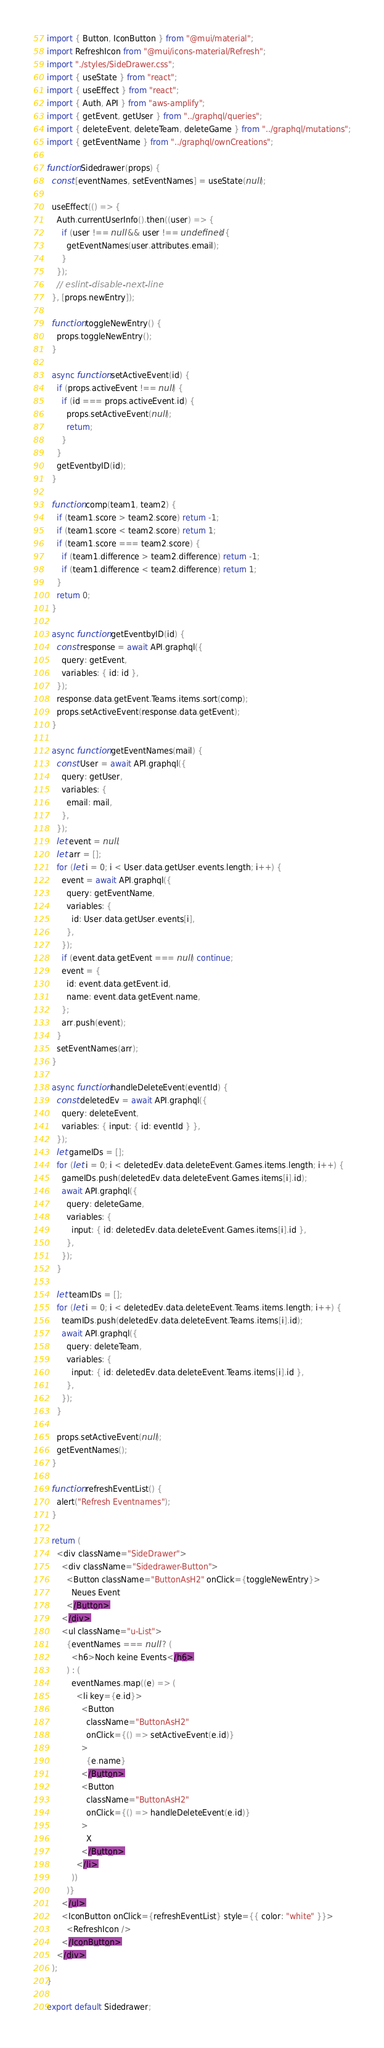Convert code to text. <code><loc_0><loc_0><loc_500><loc_500><_JavaScript_>import { Button, IconButton } from "@mui/material";
import RefreshIcon from "@mui/icons-material/Refresh";
import "./styles/SideDrawer.css";
import { useState } from "react";
import { useEffect } from "react";
import { Auth, API } from "aws-amplify";
import { getEvent, getUser } from "../graphql/queries";
import { deleteEvent, deleteTeam, deleteGame } from "../graphql/mutations";
import { getEventName } from "../graphql/ownCreations";

function Sidedrawer(props) {
  const [eventNames, setEventNames] = useState(null);

  useEffect(() => {
    Auth.currentUserInfo().then((user) => {
      if (user !== null && user !== undefined) {
        getEventNames(user.attributes.email);
      }
    });
    // eslint-disable-next-line
  }, [props.newEntry]);

  function toggleNewEntry() {
    props.toggleNewEntry();
  }

  async function setActiveEvent(id) {
    if (props.activeEvent !== null) {
      if (id === props.activeEvent.id) {
        props.setActiveEvent(null);
        return;
      }
    }
    getEventbyID(id);
  }

  function comp(team1, team2) {
    if (team1.score > team2.score) return -1;
    if (team1.score < team2.score) return 1;
    if (team1.score === team2.score) {
      if (team1.difference > team2.difference) return -1;
      if (team1.difference < team2.difference) return 1;
    }
    return 0;
  }

  async function getEventbyID(id) {
    const response = await API.graphql({
      query: getEvent,
      variables: { id: id },
    });
    response.data.getEvent.Teams.items.sort(comp);
    props.setActiveEvent(response.data.getEvent);
  }

  async function getEventNames(mail) {
    const User = await API.graphql({
      query: getUser,
      variables: {
        email: mail,
      },
    });
    let event = null;
    let arr = [];
    for (let i = 0; i < User.data.getUser.events.length; i++) {
      event = await API.graphql({
        query: getEventName,
        variables: {
          id: User.data.getUser.events[i],
        },
      });
      if (event.data.getEvent === null) continue;
      event = {
        id: event.data.getEvent.id,
        name: event.data.getEvent.name,
      };
      arr.push(event);
    }
    setEventNames(arr);
  }

  async function handleDeleteEvent(eventId) {
    const deletedEv = await API.graphql({
      query: deleteEvent,
      variables: { input: { id: eventId } },
    });
    let gameIDs = [];
    for (let i = 0; i < deletedEv.data.deleteEvent.Games.items.length; i++) {
      gameIDs.push(deletedEv.data.deleteEvent.Games.items[i].id);
      await API.graphql({
        query: deleteGame,
        variables: {
          input: { id: deletedEv.data.deleteEvent.Games.items[i].id },
        },
      });
    }

    let teamIDs = [];
    for (let i = 0; i < deletedEv.data.deleteEvent.Teams.items.length; i++) {
      teamIDs.push(deletedEv.data.deleteEvent.Teams.items[i].id);
      await API.graphql({
        query: deleteTeam,
        variables: {
          input: { id: deletedEv.data.deleteEvent.Teams.items[i].id },
        },
      });
    }

    props.setActiveEvent(null);
    getEventNames();
  }

  function refreshEventList() {
    alert("Refresh Eventnames");
  }

  return (
    <div className="SideDrawer">
      <div className="Sidedrawer-Button">
        <Button className="ButtonAsH2" onClick={toggleNewEntry}>
          Neues Event
        </Button>
      </div>
      <ul className="u-List">
        {eventNames === null ? (
          <h6>Noch keine Events</h6>
        ) : (
          eventNames.map((e) => (
            <li key={e.id}>
              <Button
                className="ButtonAsH2"
                onClick={() => setActiveEvent(e.id)}
              >
                {e.name}
              </Button>
              <Button
                className="ButtonAsH2"
                onClick={() => handleDeleteEvent(e.id)}
              >
                X
              </Button>
            </li>
          ))
        )}
      </ul>
      <IconButton onClick={refreshEventList} style={{ color: "white" }}>
        <RefreshIcon />
      </IconButton>
    </div>
  );
}

export default Sidedrawer;
</code> 